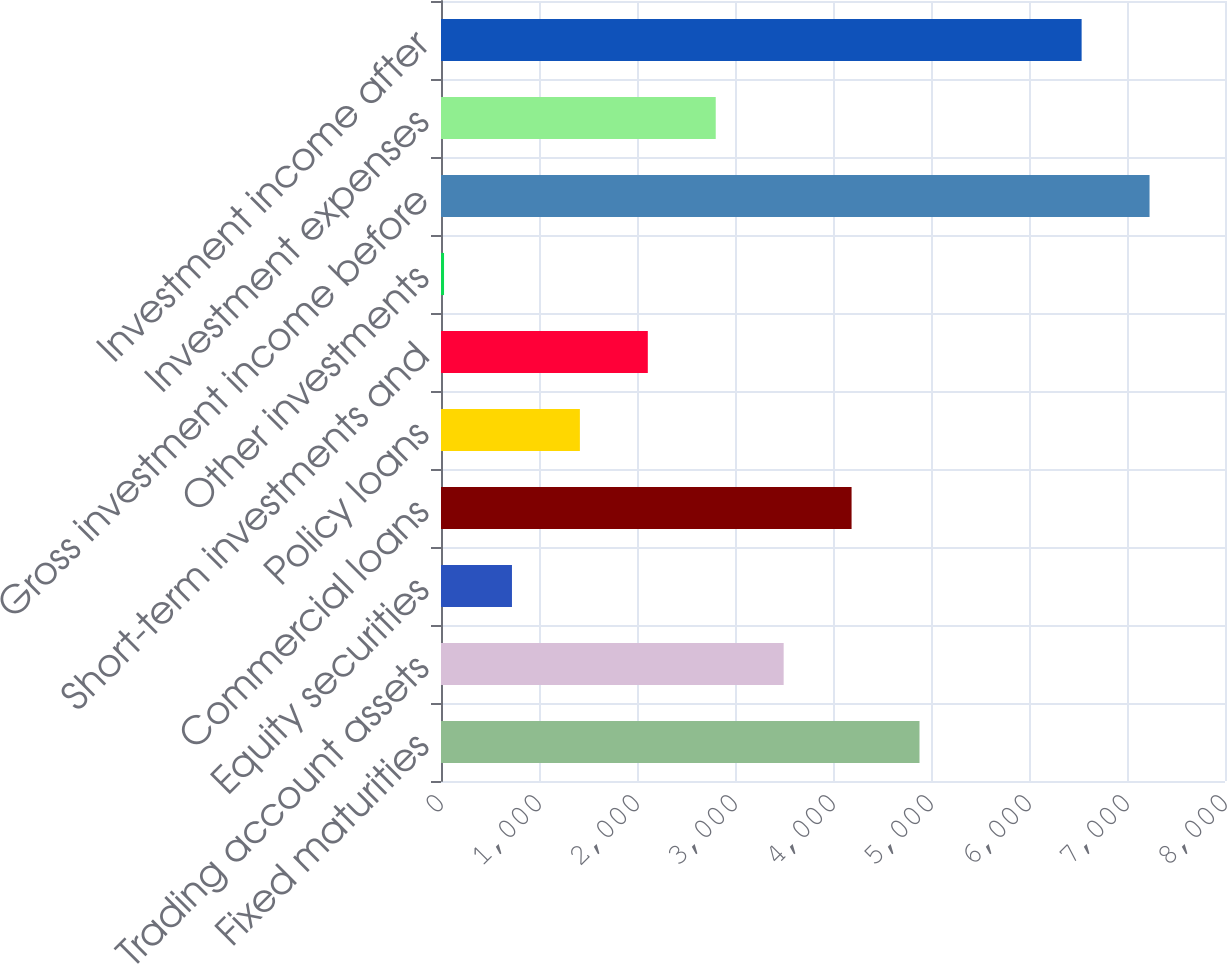Convert chart to OTSL. <chart><loc_0><loc_0><loc_500><loc_500><bar_chart><fcel>Fixed maturities<fcel>Trading account assets<fcel>Equity securities<fcel>Commercial loans<fcel>Policy loans<fcel>Short-term investments and<fcel>Other investments<fcel>Gross investment income before<fcel>Investment expenses<fcel>Investment income after<nl><fcel>4882.7<fcel>3496.5<fcel>724.1<fcel>4189.6<fcel>1417.2<fcel>2110.3<fcel>31<fcel>7230.1<fcel>2803.4<fcel>6537<nl></chart> 